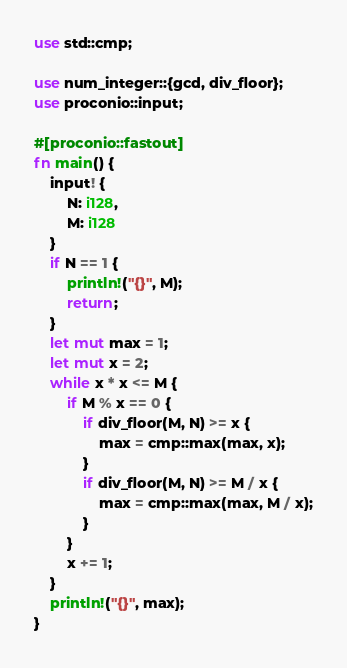<code> <loc_0><loc_0><loc_500><loc_500><_Rust_>use std::cmp;

use num_integer::{gcd, div_floor};
use proconio::input;

#[proconio::fastout]
fn main() {
    input! {
        N: i128,
        M: i128
    }
    if N == 1 {
        println!("{}", M);
        return;
    }
    let mut max = 1;
    let mut x = 2;
    while x * x <= M {
        if M % x == 0 {
            if div_floor(M, N) >= x {
                max = cmp::max(max, x);
            }
            if div_floor(M, N) >= M / x {
                max = cmp::max(max, M / x);
            }
        }
        x += 1;
    }
    println!("{}", max);
}
</code> 